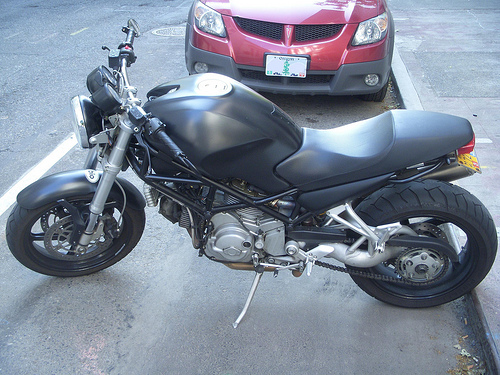<image>
Is there a motorcycle on the car? No. The motorcycle is not positioned on the car. They may be near each other, but the motorcycle is not supported by or resting on top of the car. Is there a motorcycle behind the car? No. The motorcycle is not behind the car. From this viewpoint, the motorcycle appears to be positioned elsewhere in the scene. 